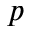Convert formula to latex. <formula><loc_0><loc_0><loc_500><loc_500>p</formula> 